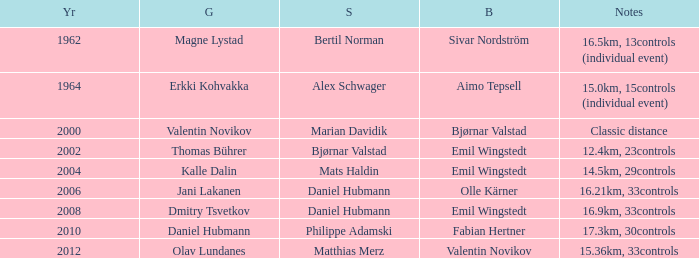WHAT YEAR HAS A SILVER FOR MATTHIAS MERZ? 2012.0. 